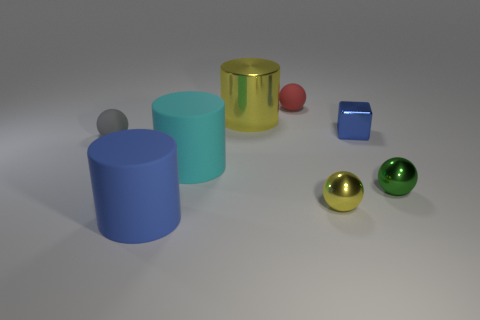What can you infer about the texture of the objects in the image? The objects in the image seem to have a smooth texture. The reflective qualities of the metallic surfaces and the even color distributions on the matte objects all suggest that these items have been designed to display as smooth and sleek, devoid of any apparent roughness or textural irregularities. 